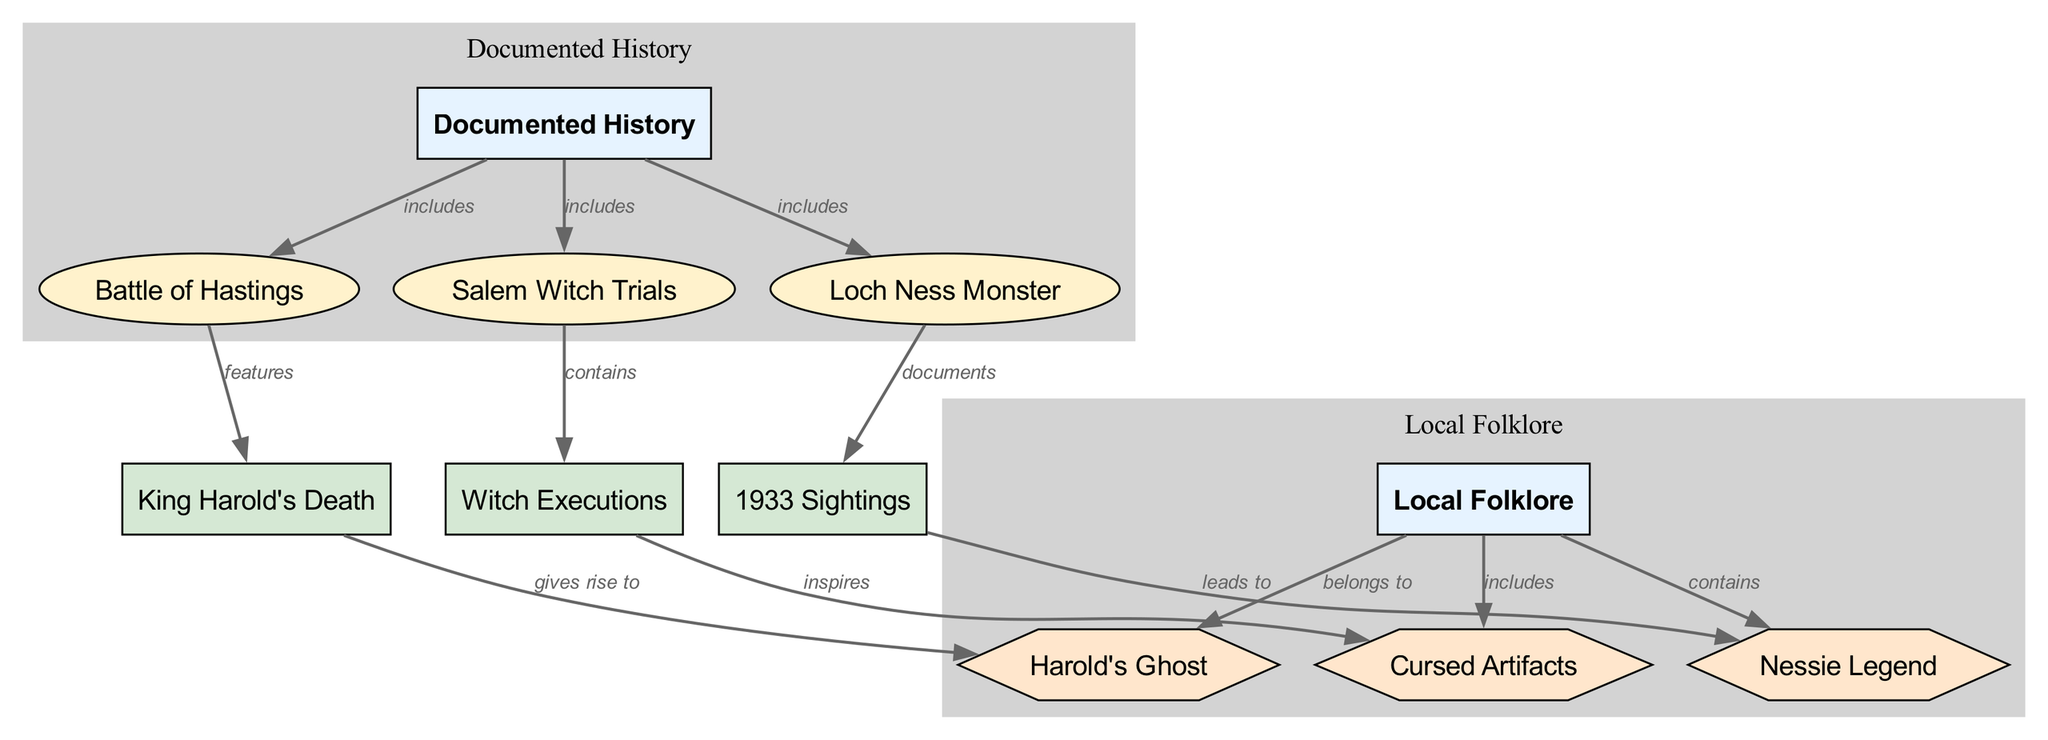What are the three events included in documented history? The diagram lists three specific events under the 'Documented History' category: the Battle of Hastings, the Salem Witch Trials, and the Loch Ness Monster.
Answer: Battle of Hastings, Salem Witch Trials, Loch Ness Monster Which node features the historical fact of King Harold's Death? The diagram connects the 'Battle of Hastings' node to 'King Harold's Death' with the label 'features'. Thus, 'King Harold's Death' is featured within the context of the 'Battle of Hastings'.
Answer: King Harold's Death How many folklore elements belong to local folklore? The diagram shows three folklore elements connected to the 'Local Folklore' category: Harold's Ghost, Cursed Artifacts, and Nessie Legend. Hence, there are three folklore elements.
Answer: 3 What does the historical fact of Witch Executions inspire? According to the diagram, 'Witch Executions' is linked to 'Cursed Artifacts' with the label 'inspires', indicating that the historical fact gives rise to or inspires the folklore.
Answer: Cursed Artifacts Which documented event includes a fact about the 1933 Sightings? The 'Loch Ness Monster' node is related to the historical fact '1933 Sightings' with the label 'documents'. Therefore, the 'Loch Ness Monster' is the documented event that includes this fact.
Answer: Loch Ness Monster What does Harold's Ghost belong to? The diagram indicates that 'Harold's Ghost' is connected to the 'Local Folklore' category with the label 'belongs to', which identifies it as a piece of folklore.
Answer: Local Folklore Which event contains the fact of witch executions? The connection indicates that the 'Salem Witch Trials' node contains the historical fact of 'Witch Executions', meaning it is included within the context of those trials.
Answer: Salem Witch Trials Which folklore includes the Nessie Legend? The diagram shows that 'Nessie Legend' is connected to 'Local Folklore' with the label 'contains', indicating that the legend itself is a part of the folklore.
Answer: Local Folklore 